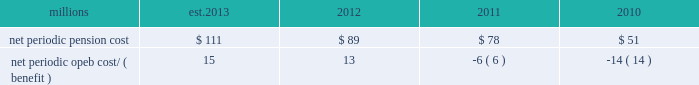The table presents the net periodic pension and opeb cost/ ( benefit ) for the years ended december 31 : millions 2013 2012 2011 2010 .
Our net periodic pension cost is expected to increase to approximately $ 111 million in 2013 from $ 89 million in 2012 .
The increase is driven mainly by a decrease in the discount rate to 3.78% ( 3.78 % ) , our net periodic opeb expense is expected to increase to approximately $ 15 million in 2013 from $ 13 million in 2012 .
The increase in our net periodic opeb cost is primarily driven by a decrease in the discount rate to 3.48% ( 3.48 % ) .
Cautionary information certain statements in this report , and statements in other reports or information filed or to be filed with the sec ( as well as information included in oral statements or other written statements made or to be made by us ) , are , or will be , forward-looking statements as defined by the securities act of 1933 and the securities exchange act of 1934 .
These forward-looking statements and information include , without limitation , ( a ) statements in the ceo 2019s letter preceding part i ; statements regarding planned capital expenditures under the caption 201c2013 capital expenditures 201d in item 2 of part i ; statements regarding dividends in item 5 ; and statements and information set forth under the captions 201c2013 outlook 201d and 201cliquidity and capital resources 201d in this item 7 , and ( b ) any other statements or information in this report ( including information incorporated herein by reference ) regarding : expectations as to financial performance , revenue growth and cost savings ; the time by which goals , targets , or objectives will be achieved ; projections , predictions , expectations , estimates , or forecasts as to our business , financial and operational results , future economic performance , and general economic conditions ; expectations as to operational or service performance or improvements ; expectations as to the effectiveness of steps taken or to be taken to improve operations and/or service , including capital expenditures for infrastructure improvements and equipment acquisitions , any strategic business acquisitions , and modifications to our transportation plans ( including statements set forth in item 2 as to expectations related to our planned capital expenditures ) ; expectations as to existing or proposed new products and services ; expectations as to the impact of any new regulatory activities or legislation on our operations or financial results ; estimates of costs relating to environmental remediation and restoration ; estimates and expectations regarding tax matters ; expectations that claims , litigation , environmental costs , commitments , contingent liabilities , labor negotiations or agreements , or other matters will not have a material adverse effect on our consolidated results of operations , financial condition , or liquidity and any other similar expressions concerning matters that are not historical facts .
Forward-looking statements may be identified by their use of forward-looking terminology , such as 201cbelieves , 201d 201cexpects , 201d 201cmay , 201d 201cshould , 201d 201cwould , 201d 201cwill , 201d 201cintends , 201d 201cplans , 201d 201cestimates , 201d 201canticipates , 201d 201cprojects 201d and similar words , phrases or expressions .
Forward-looking statements should not be read as a guarantee of future performance or results , and will not necessarily be accurate indications of the times that , or by which , such performance or results will be achieved .
Forward-looking statements and information are subject to risks and uncertainties that could cause actual performance or results to differ materially from those expressed in the statements and information .
Forward-looking statements and information reflect the good faith consideration by management of currently available information , and may be based on underlying assumptions believed to be reasonable under the circumstances .
However , such information and assumptions ( and , therefore , such forward-looking statements and information ) are or may be subject to variables or unknown or unforeseeable events or circumstances over which management has little or no influence or control .
The risk factors in item 1a of this report could affect our future results and could cause those results or other outcomes to differ materially from those expressed or implied in any forward-looking statements or information .
To the extent circumstances require or we deem it otherwise necessary , we will update or amend these risk factors in a form 10-q , form 8-k or subsequent form 10-k .
All forward-looking statements are qualified by , and should be read in conjunction with , these risk factors .
Forward-looking statements speak only as of the date the statement was made .
We assume no obligation to update forward-looking information to reflect actual results , changes in assumptions or changes in other factors affecting forward-looking information .
If we do update one or more forward-looking .
What is the estimated growth rate in net periodic pension cost from 2011 to 2012? 
Computations: ((89 - 78) / 78)
Answer: 0.14103. 